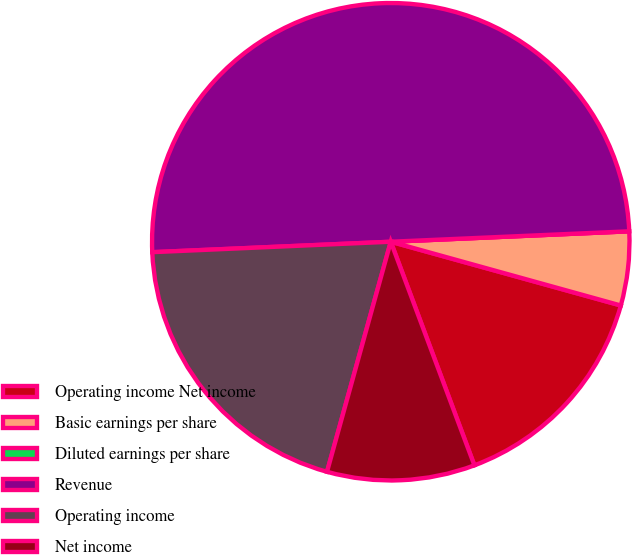Convert chart to OTSL. <chart><loc_0><loc_0><loc_500><loc_500><pie_chart><fcel>Operating income Net income<fcel>Basic earnings per share<fcel>Diluted earnings per share<fcel>Revenue<fcel>Operating income<fcel>Net income<nl><fcel>15.0%<fcel>5.0%<fcel>0.0%<fcel>50.0%<fcel>20.0%<fcel>10.0%<nl></chart> 